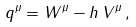Convert formula to latex. <formula><loc_0><loc_0><loc_500><loc_500>q ^ { \mu } = W ^ { \mu } - h \, V ^ { \mu } \, ,</formula> 